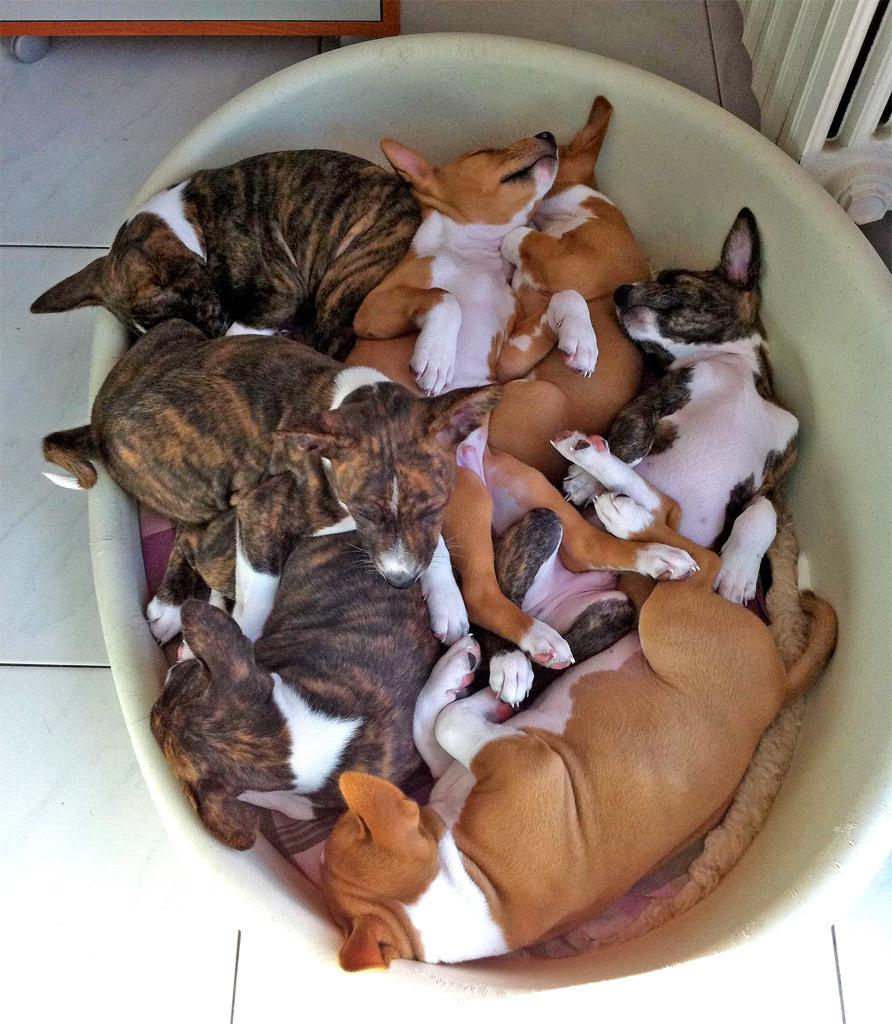What type of animals can be seen in the image? There are dogs in the image. What are the dogs doing in the image? The dogs are sleeping in a tub. What is the surface beneath the dogs? There is a floor in the image. What type of object with wheels can be seen in the image? There is an object with wheels in the image. Reasoning: Let' Let's think step by step in order to produce the conversation. We start by identifying the main subject of the image, which are the dogs. Then, we describe their actions, which is sleeping in a tub. Next, we mention the surface beneath them, which is the floor. Finally, we identify another object in the image, which has wheels. Each question is designed to elicit a specific detail about the image that is known from the provided facts. Absurd Question/Answer: What is the name of the daughter in the image? There is no daughter present in the image; it features dogs sleeping in a tub. In which direction are the dogs facing in the image? The provided facts do not specify the direction the dogs are facing in the image. 